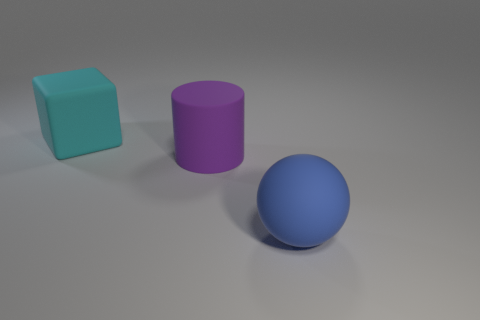There is a matte object that is left of the matte cylinder; what shape is it?
Ensure brevity in your answer.  Cube. There is a large rubber block; how many big matte cylinders are right of it?
Offer a terse response. 1. Is there anything else that has the same shape as the big purple matte object?
Offer a very short reply. No. Is the number of rubber blocks that are left of the rubber sphere greater than the number of brown metallic cylinders?
Your answer should be very brief. Yes. What number of big cyan matte objects are in front of the big object that is behind the large purple rubber cylinder?
Offer a very short reply. 0. Is there a big object made of the same material as the big purple cylinder?
Ensure brevity in your answer.  Yes. Are there the same number of cyan rubber objects in front of the purple thing and blue metal balls?
Your response must be concise. Yes. The purple object has what shape?
Make the answer very short. Cylinder. What number of things are either red metal balls or blue matte balls?
Ensure brevity in your answer.  1. Do the cyan block that is behind the cylinder and the large sphere have the same material?
Provide a short and direct response. Yes. 